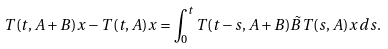<formula> <loc_0><loc_0><loc_500><loc_500>T ( t , A + B ) x - T ( t , A ) x = \int _ { 0 } ^ { t } T ( t - s , A + B ) \tilde { B } T ( s , A ) x \, d s .</formula> 